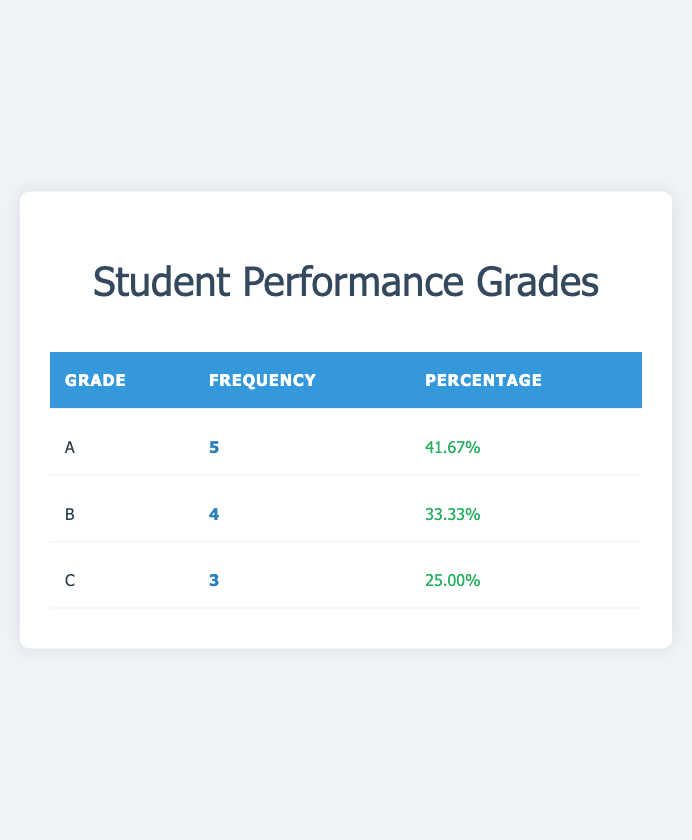What is the total number of students represented in the table? The table shows the frequencies of grades A, B, and C. Adding the frequencies, we get 5 (A) + 4 (B) + 3 (C) = 12.
Answer: 12 How many students received a grade of B? The table indicates that 4 students received a grade of B.
Answer: 4 What percentage of students achieved a grade A? The table shows that 41.67% of the students received a grade A. We confirm this by looking specifically at the percentage column for grade A.
Answer: 41.67% Is it true that more students received an A than a C? By comparing the counts, 5 students received an A, while 3 students received a C. Since 5 is greater than 3, the statement is true.
Answer: Yes If a student is randomly selected, what is the probability of selecting a student who received a grade B or C? The number of students receiving a grade B is 4 and for C is 3. Adding these gives 4 + 3 = 7 students who received either grade B or C. Therefore, the probability is 7 out of 12 students, or 7/12.
Answer: 7/12 What is the ratio of students who received an A to those who received a C? The number of students who received an A is 5, while the number of students who received a C is 3. The ratio of A to C is 5:3.
Answer: 5:3 Which grade has the lowest frequency, and how many students received it? The table shows that grade C has the lowest frequency with 3 students. By comparing the frequencies (5 for A, 4 for B, and 3 for C), we can see that C is the lowest.
Answer: C, 3 students What is the difference in the number of students between those who received an A and those who received a B? There are 5 students who received an A and 4 who received a B. The difference is calculated as 5 - 4 = 1.
Answer: 1 What grade has a frequency that is one-third of the total number of students? The total number of students is 12. One-third of 12 equals 4. Referring to the table, the grade B has a frequency of 4, satisfying the condition of being one-third of the total.
Answer: B 